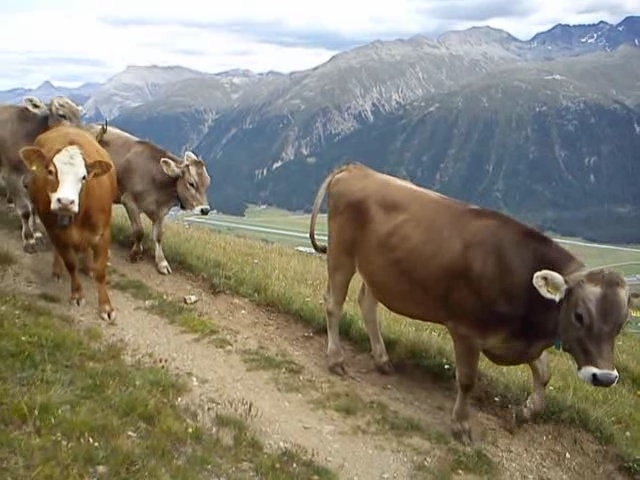Describe the objects in this image and their specific colors. I can see cow in white, black, maroon, and gray tones, cow in white, maroon, brown, and ivory tones, cow in white, gray, maroon, and black tones, and cow in white, gray, and black tones in this image. 